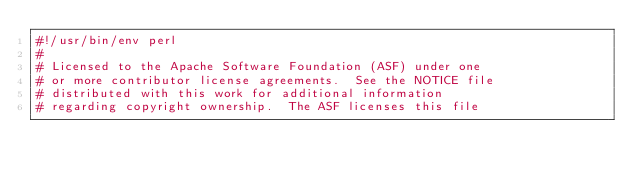<code> <loc_0><loc_0><loc_500><loc_500><_Perl_>#!/usr/bin/env perl
#
# Licensed to the Apache Software Foundation (ASF) under one
# or more contributor license agreements.  See the NOTICE file
# distributed with this work for additional information
# regarding copyright ownership.  The ASF licenses this file</code> 